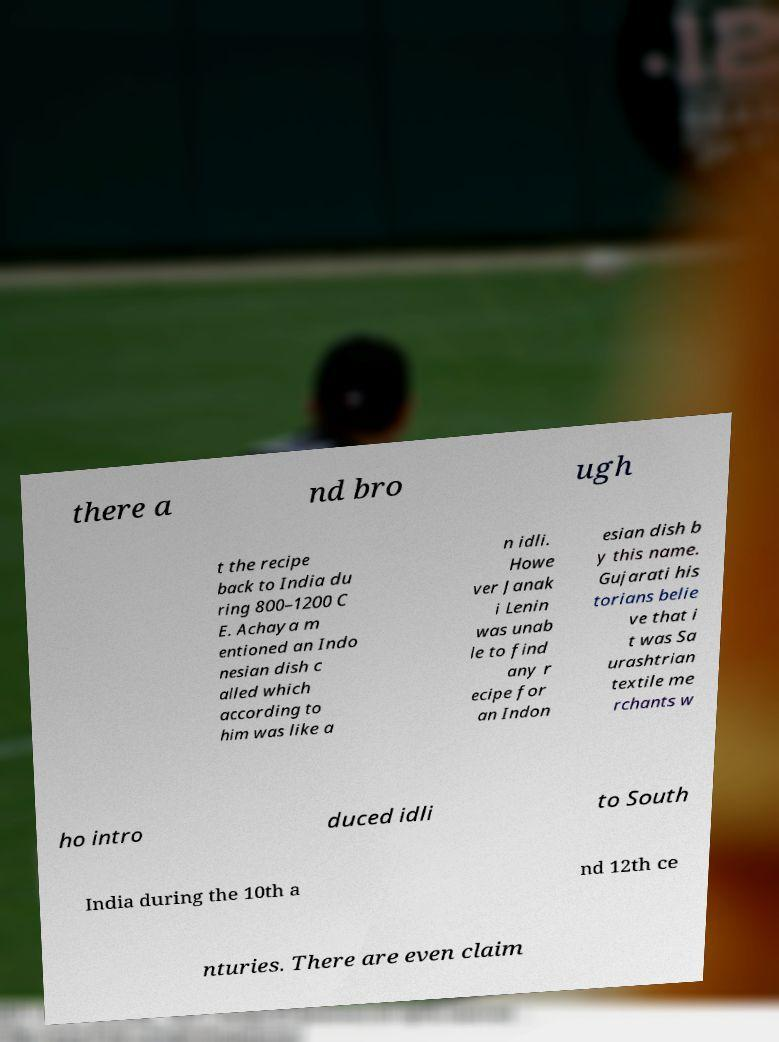Could you assist in decoding the text presented in this image and type it out clearly? there a nd bro ugh t the recipe back to India du ring 800–1200 C E. Achaya m entioned an Indo nesian dish c alled which according to him was like a n idli. Howe ver Janak i Lenin was unab le to find any r ecipe for an Indon esian dish b y this name. Gujarati his torians belie ve that i t was Sa urashtrian textile me rchants w ho intro duced idli to South India during the 10th a nd 12th ce nturies. There are even claim 